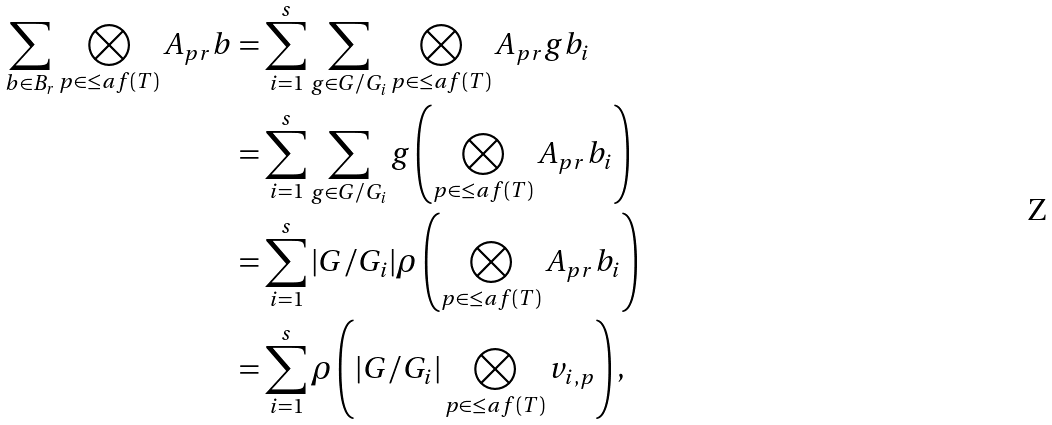<formula> <loc_0><loc_0><loc_500><loc_500>\sum _ { b \in B _ { r } } \bigotimes _ { p \in \leq a f ( T ) } A _ { p r } b & = \sum _ { i = 1 } ^ { s } \sum _ { g \in G / G _ { i } } \bigotimes _ { p \in \leq a f ( T ) } A _ { p r } g b _ { i } \\ & = \sum _ { i = 1 } ^ { s } \sum _ { g \in G / G _ { i } } g \left ( \bigotimes _ { p \in \leq a f ( T ) } A _ { p r } b _ { i } \right ) \\ & = \sum _ { i = 1 } ^ { s } | G / G _ { i } | \rho \left ( \bigotimes _ { p \in \leq a f ( T ) } A _ { p r } b _ { i } \right ) \\ & = \sum _ { i = 1 } ^ { s } \rho \left ( | G / G _ { i } | \bigotimes _ { p \in \leq a f ( T ) } v _ { i , p } \right ) ,</formula> 